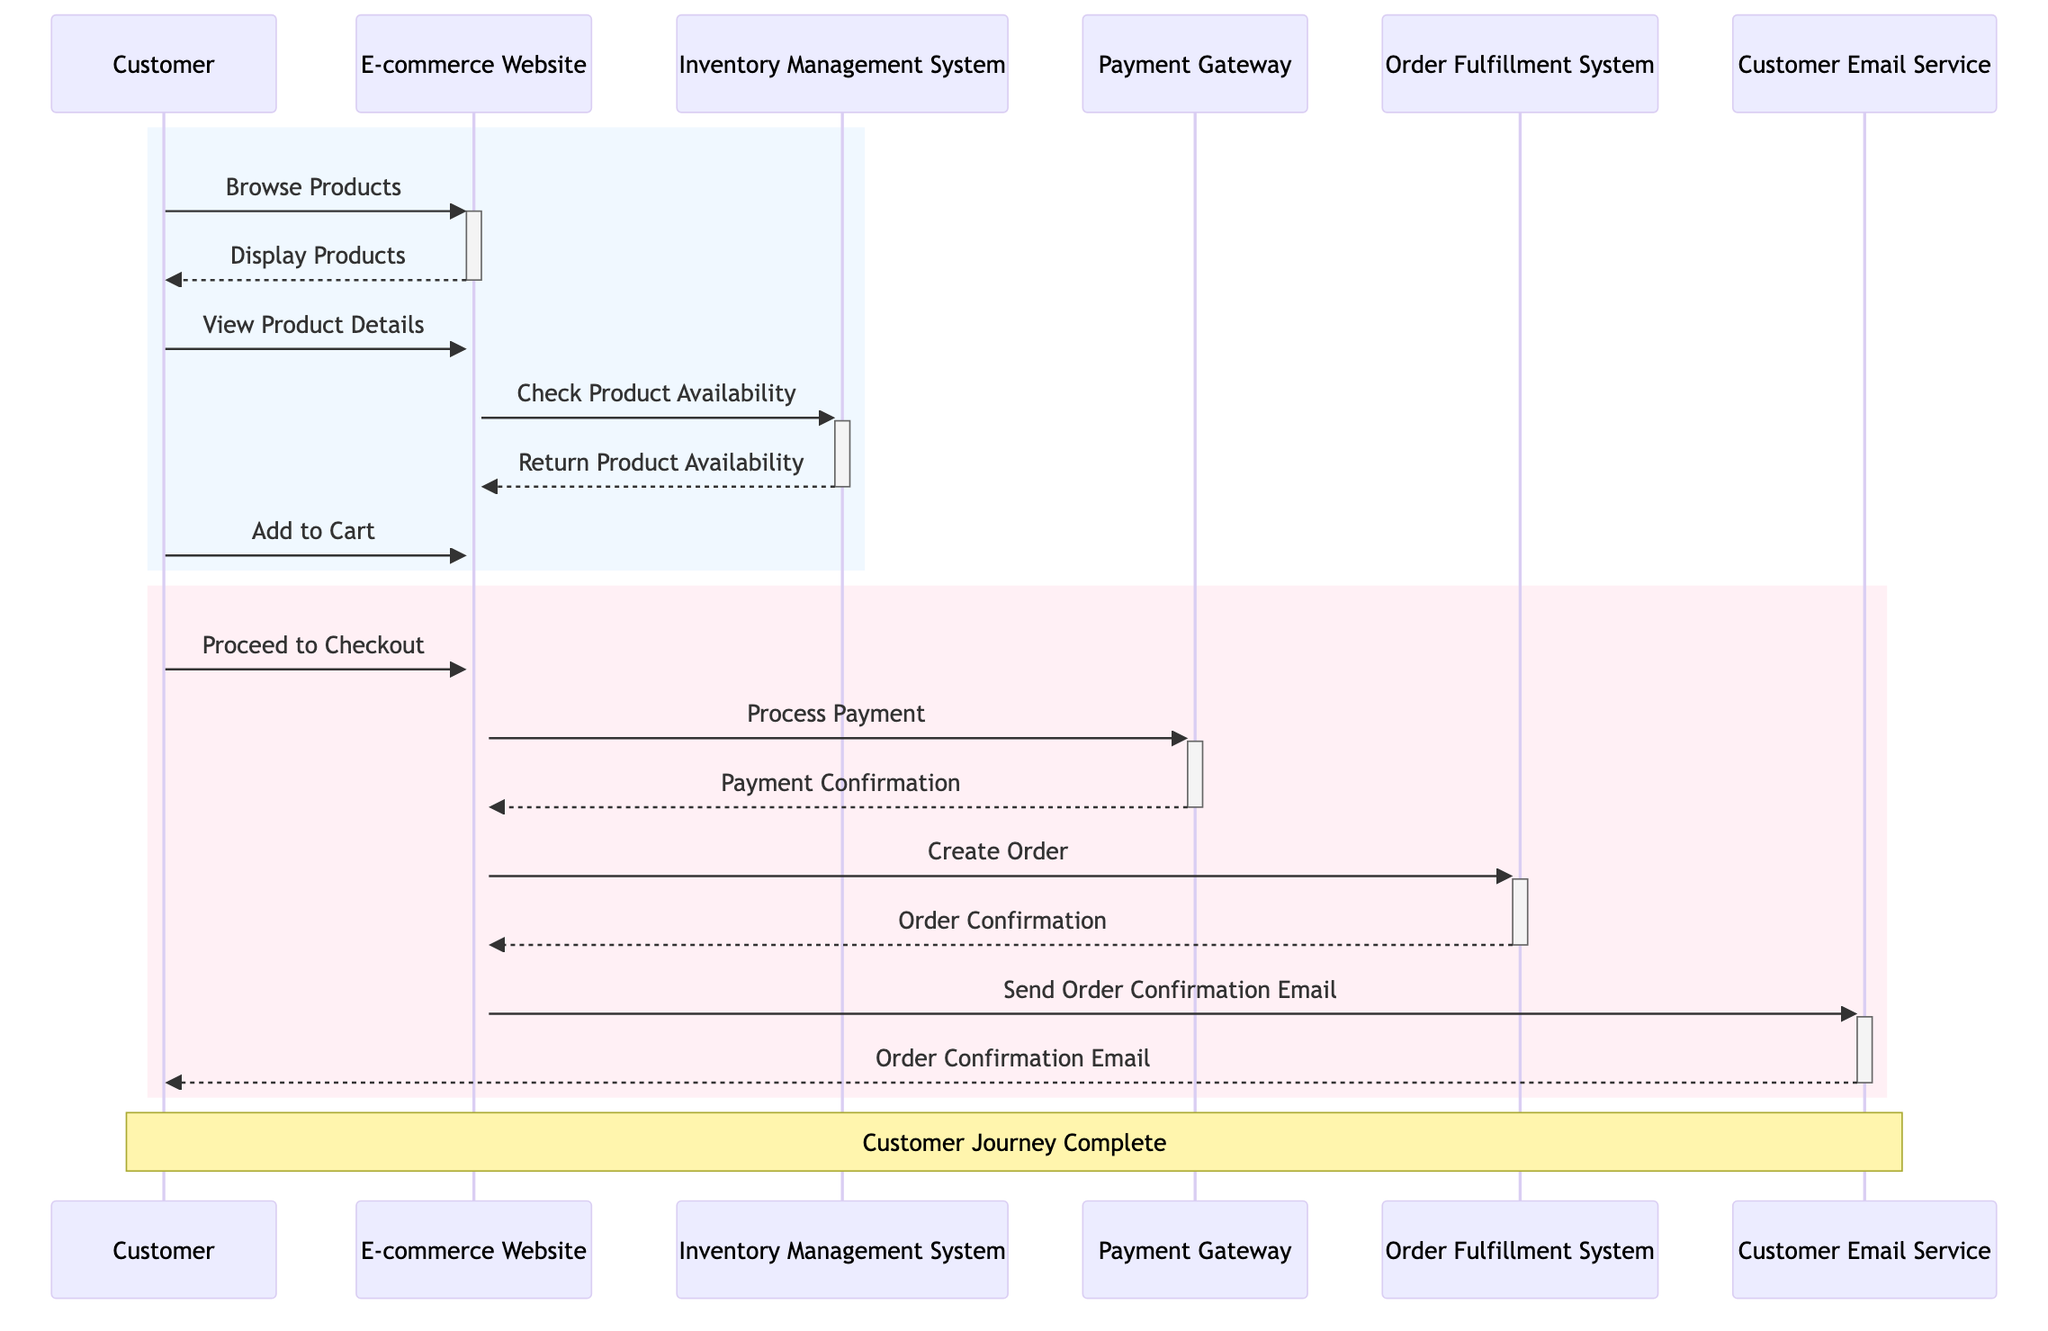What is the first action taken by the Customer? The Customer first interacts with the E-commerce Website by sending the message "Browse Products." This is the initial interaction depicted in the diagram.
Answer: Browse Products How many systems are involved in the Customer Journey? The diagram lists several systems and subsystems involved in the journey: E-commerce Website, Inventory Management System, Payment Gateway, Order Fulfillment System, and Customer Email Service. Counting these gives a total of five systems.
Answer: Five What message is sent from the E-commerce Website to the Inventory Management System? The E-commerce Website checks product availability by sending the message "Check Product Availability" to the Inventory Management System as part of the customer's journey.
Answer: Check Product Availability What does the Customer do after viewing product details? After viewing product details, the Customer adds the item to the cart by sending the message "Add to Cart" to the E-commerce Website. This action proceeds after product details are viewed as indicated in the diagram.
Answer: Add to Cart Which system is responsible for processing the payment? The Payment Gateway is responsible for processing the payment following the confirmation of the Customer's intention to proceed to checkout. This is shown in the sequence of messages exchanged in the diagram.
Answer: Payment Gateway How many steps are involved from adding to the cart to receiving the order confirmation email? The sequence consists of five steps from "Add to Cart," "Proceed to Checkout," "Process Payment," "Create Order," and "Send Order Confirmation Email," culminating in the "Order Confirmation Email" received by the Customer. Therefore, there are five steps involved.
Answer: Five What is sent back from the Order Fulfillment System to the E-commerce Website? The Order Fulfillment System sends back the message "Order Confirmation" to the E-commerce Website after the order is created, indicating that the order has been successfully processed.
Answer: Order Confirmation Which message is the last action in the Customer Journey? The final action in the Customer Journey is the "Order Confirmation Email" sent from the Customer Email Service to the Customer, which completes the entire transaction process depicted in the diagram.
Answer: Order Confirmation Email What is the relationship between the E-commerce Website and the Payment Gateway? The relationship is that the E-commerce Website sends the message "Process Payment" to the Payment Gateway, indicating a direct interaction for payment processing after the Customer decides to proceed to checkout.
Answer: Process Payment 